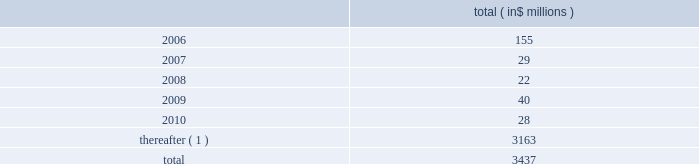Celanese corporation and subsidiaries notes to consolidated financial statements ( continued ) 2022 amend certain material agreements governing bcp crystal 2019s indebtedness ; 2022 change the business conducted by celanese holdings and its subsidiaries ; and 2022 enter into hedging agreements that restrict dividends from subsidiaries .
In addition , the senior credit facilities require bcp crystal to maintain the following financial covenants : a maximum total leverage ratio , a maximum bank debt leverage ratio , a minimum interest coverage ratio and maximum capital expenditures limitation .
The maximum consolidated net bank debt to adjusted ebitda ratio , as defined , previously required under the senior credit facilities , was eliminated when the company amended the facilities in january 2005 .
As of december 31 , 2005 , the company was in compliance with all of the financial covenants related to its debt agreements .
The maturation of the company 2019s debt , including short term borrowings , is as follows : ( in $ millions ) .
( 1 ) includes $ 2 million purchase accounting adjustment to assumed debt .
17 .
Benefit obligations pension obligations .
Pension obligations are established for benefits payable in the form of retirement , disability and surviving dependent pensions .
The benefits offered vary according to the legal , fiscal and economic conditions of each country .
The commitments result from participation in defined contribution and defined benefit plans , primarily in the u.s .
Benefits are dependent on years of service and the employee 2019s compensation .
Supplemental retirement benefits provided to certain employees are non-qualified for u.s .
Tax purposes .
Separate trusts have been established for some non-qualified plans .
Defined benefit pension plans exist at certain locations in north america and europe .
As of december 31 , 2005 , the company 2019s u.s .
Qualified pension plan represented greater than 85% ( 85 % ) and 75% ( 75 % ) of celanese 2019s pension plan assets and liabilities , respectively .
Independent trusts or insurance companies administer the majority of these plans .
Actuarial valuations for these plans are prepared annually .
The company sponsors various defined contribution plans in europe and north america covering certain employees .
Employees may contribute to these plans and the company will match these contributions in varying amounts .
Contributions to the defined contribution plans are based on specified percentages of employee contributions and they aggregated $ 12 million for the year ended decem- ber 31 , 2005 , $ 8 million for the nine months ended december 31 , 2004 , $ 3 million for the three months ended march 31 , 2004 and $ 11 million for the year ended december 31 , 2003 .
In connection with the acquisition of cag , the purchaser agreed to pre-fund $ 463 million of certain pension obligations .
During the nine months ended december 31 , 2004 , $ 409 million was pre-funded to the company 2019s pension plans .
The company contributed an additional $ 54 million to the non-qualified pension plan 2019s rabbi trusts in february 2005 .
In connection with the company 2019s acquisition of vinamul and acetex , the company assumed certain assets and obligations related to the acquired pension plans .
The company recorded liabilities of $ 128 million for these pension plans .
Total pension assets acquired amounted to $ 85 million. .
What is the percent of maturation of the company 2019s debt , including short term borrowings that will occur in the period after 2010 as part of the total? 
Rationale: approximately 93% of debt maturation will occur in the period after 2010
Computations: (3163 / 3437)
Answer: 0.92028. 